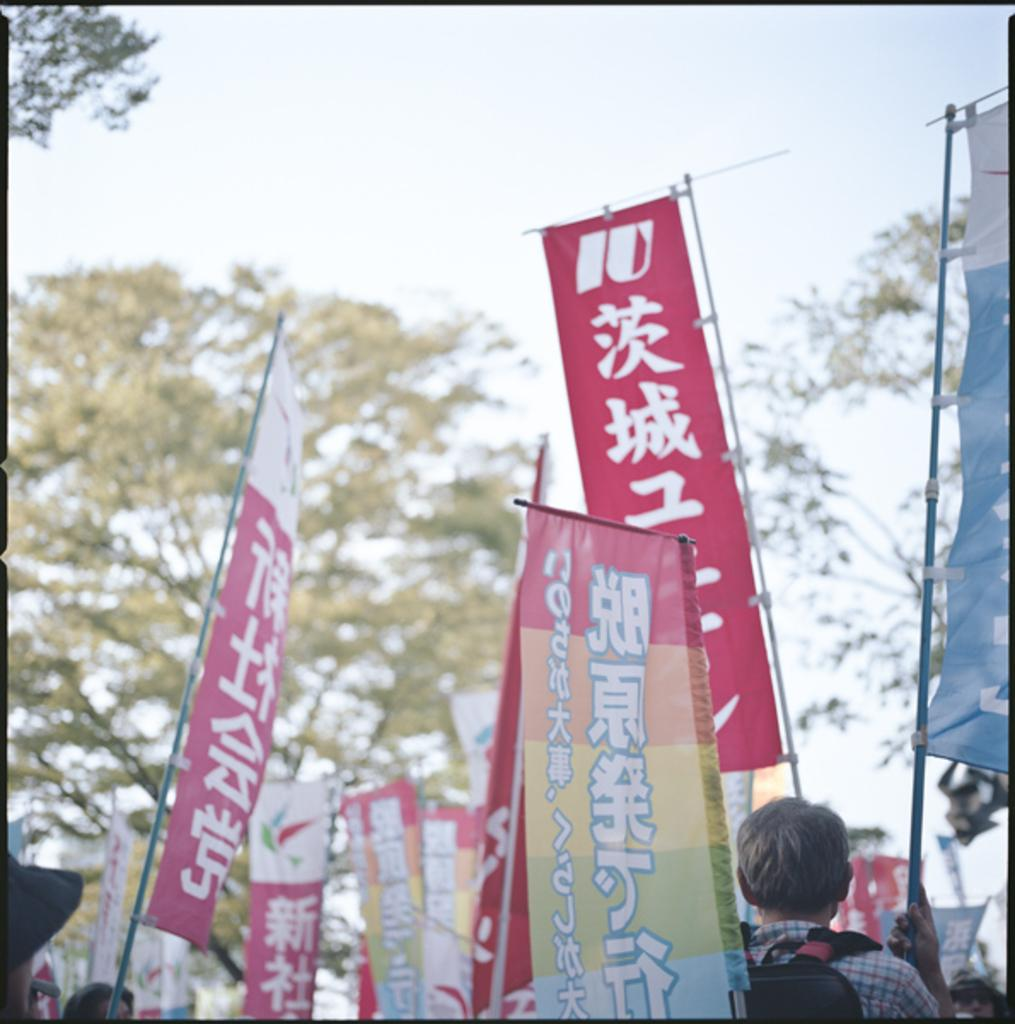What objects are located in the center of the image? There are boards in the center of the image. What type of natural elements can be seen in the image? Trees are present in the image. What are the persons in the image doing with the boards? The persons are holding the boards at the bottom of the image. What is visible at the top of the image? The sky is visible at the top of the image. How many children are sitting on the furniture in the image? There are no children or furniture present in the image. What type of hydrant can be seen near the trees in the image? There is no hydrant present in the image; only trees and boards are visible. 